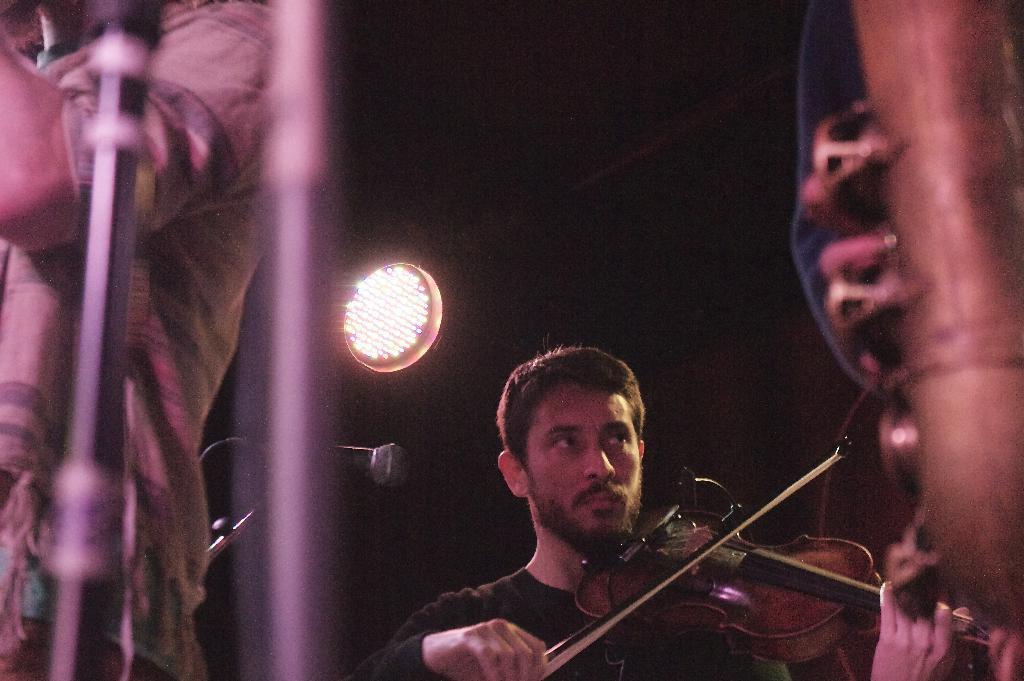Can you describe this image briefly? As we can see in the image there is a light, two people over here and there is a mic. the man who is standing over here is wearing black color shirt and playing a guitar. 